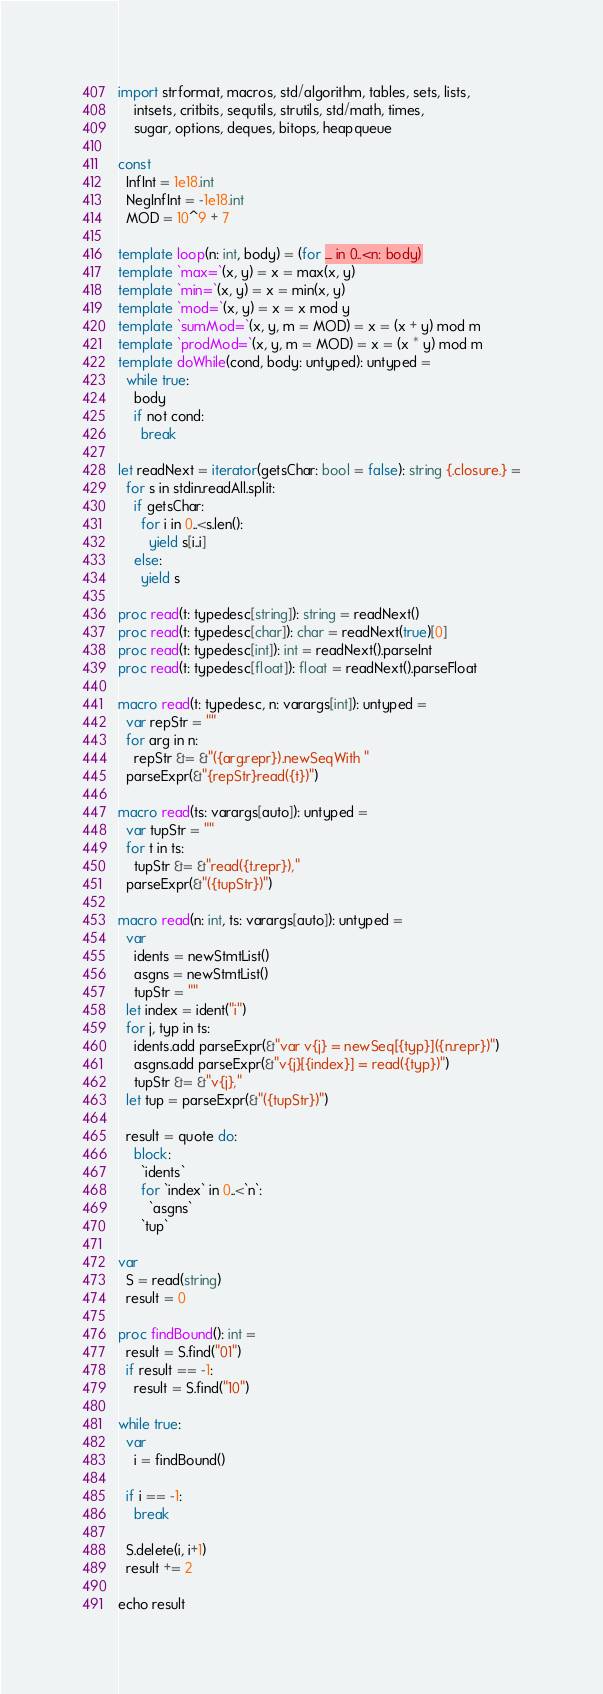Convert code to text. <code><loc_0><loc_0><loc_500><loc_500><_Nim_>import strformat, macros, std/algorithm, tables, sets, lists,
    intsets, critbits, sequtils, strutils, std/math, times,
    sugar, options, deques, bitops, heapqueue

const
  InfInt = 1e18.int
  NegInfInt = -1e18.int
  MOD = 10^9 + 7

template loop(n: int, body) = (for _ in 0..<n: body)
template `max=`(x, y) = x = max(x, y)
template `min=`(x, y) = x = min(x, y)
template `mod=`(x, y) = x = x mod y
template `sumMod=`(x, y, m = MOD) = x = (x + y) mod m
template `prodMod=`(x, y, m = MOD) = x = (x * y) mod m
template doWhile(cond, body: untyped): untyped =
  while true:
    body
    if not cond:
      break

let readNext = iterator(getsChar: bool = false): string {.closure.} =
  for s in stdin.readAll.split:
    if getsChar:
      for i in 0..<s.len():
        yield s[i..i]
    else:
      yield s

proc read(t: typedesc[string]): string = readNext()
proc read(t: typedesc[char]): char = readNext(true)[0]
proc read(t: typedesc[int]): int = readNext().parseInt
proc read(t: typedesc[float]): float = readNext().parseFloat

macro read(t: typedesc, n: varargs[int]): untyped =
  var repStr = ""
  for arg in n:
    repStr &= &"({arg.repr}).newSeqWith "
  parseExpr(&"{repStr}read({t})")

macro read(ts: varargs[auto]): untyped =
  var tupStr = ""
  for t in ts:
    tupStr &= &"read({t.repr}),"
  parseExpr(&"({tupStr})")

macro read(n: int, ts: varargs[auto]): untyped =
  var
    idents = newStmtList()
    asgns = newStmtList()
    tupStr = ""
  let index = ident("i")
  for j, typ in ts:
    idents.add parseExpr(&"var v{j} = newSeq[{typ}]({n.repr})")
    asgns.add parseExpr(&"v{j}[{index}] = read({typ})")
    tupStr &= &"v{j},"
  let tup = parseExpr(&"({tupStr})")

  result = quote do:
    block:
      `idents`
      for `index` in 0..<`n`:
        `asgns`
      `tup`

var
  S = read(string)
  result = 0

proc findBound(): int =
  result = S.find("01")
  if result == -1:
    result = S.find("10")

while true:
  var
    i = findBound()

  if i == -1:
    break

  S.delete(i, i+1)
  result += 2

echo result
</code> 